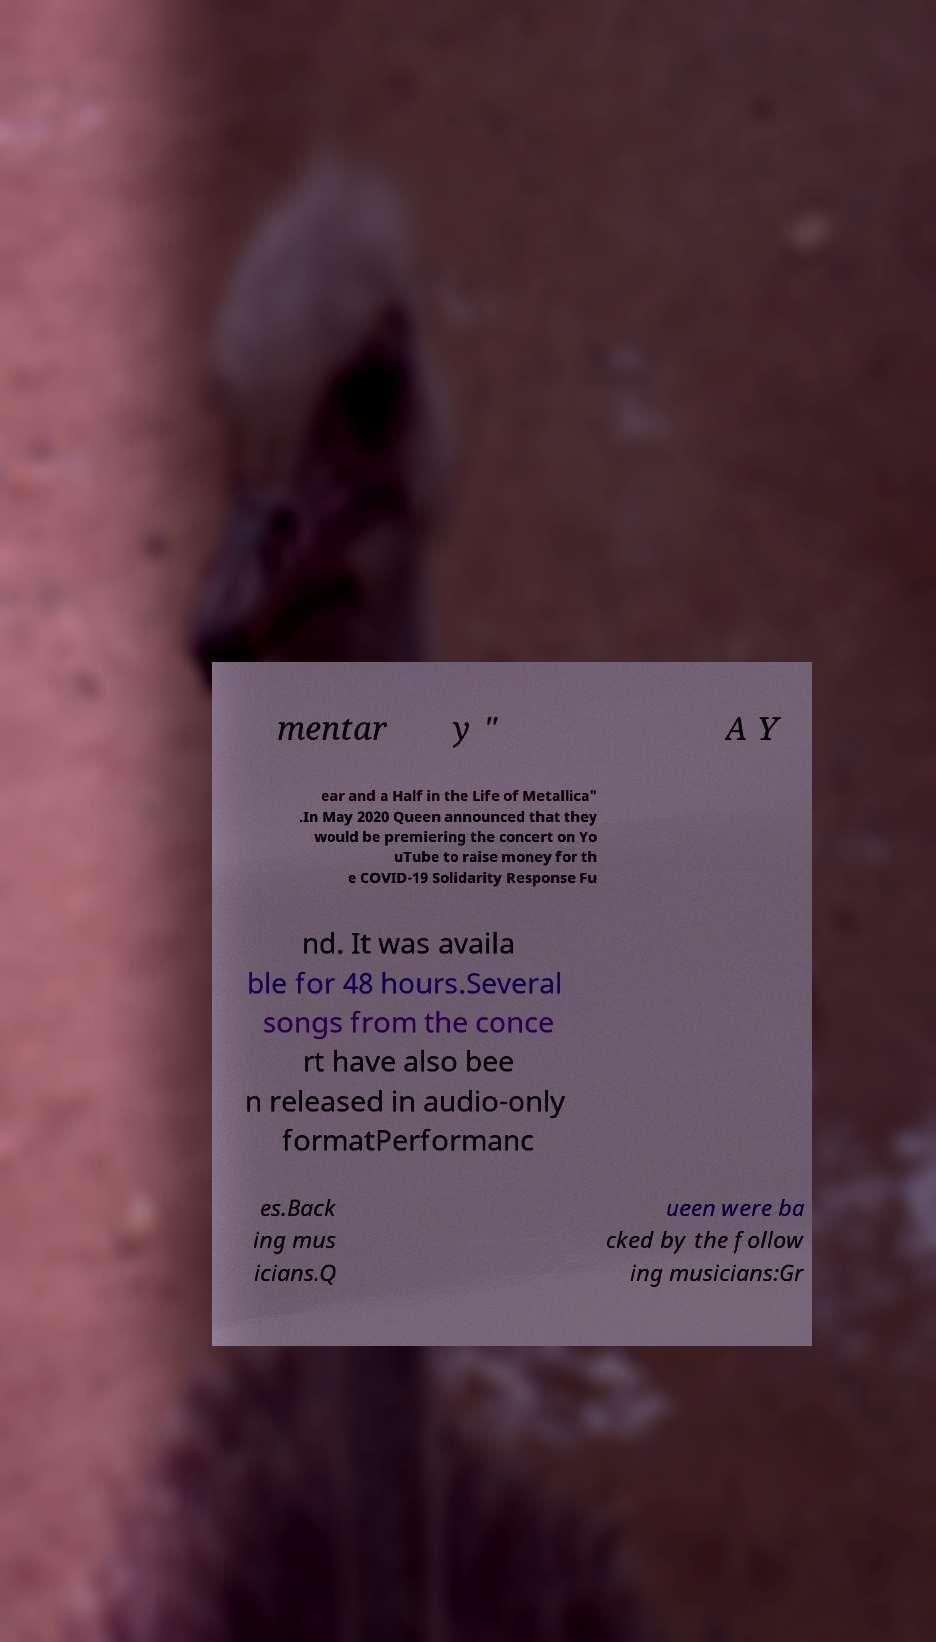Could you extract and type out the text from this image? mentar y " A Y ear and a Half in the Life of Metallica" .In May 2020 Queen announced that they would be premiering the concert on Yo uTube to raise money for th e COVID-19 Solidarity Response Fu nd. It was availa ble for 48 hours.Several songs from the conce rt have also bee n released in audio-only formatPerformanc es.Back ing mus icians.Q ueen were ba cked by the follow ing musicians:Gr 